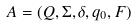<formula> <loc_0><loc_0><loc_500><loc_500>A = ( Q , \Sigma , \delta , q _ { 0 } , F )</formula> 